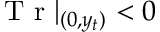<formula> <loc_0><loc_0><loc_500><loc_500>T r | _ { ( 0 , y _ { t } ) } < 0</formula> 